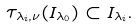Convert formula to latex. <formula><loc_0><loc_0><loc_500><loc_500>\tau _ { \lambda _ { i } , \nu } ( I _ { \lambda _ { 0 } } ) \subset I _ { \lambda _ { i } } .</formula> 